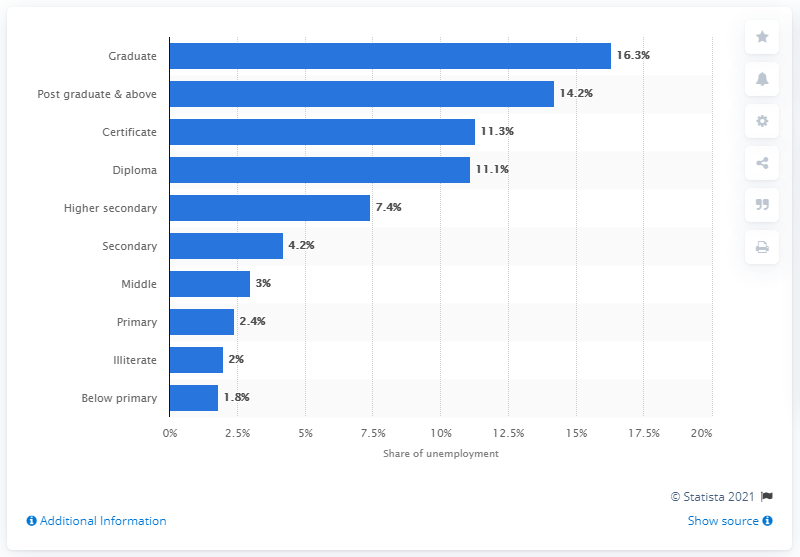Can you infer from the image which degree levels have almost the same rate of unemployment? Yes, according to the image, individuals with diploma and certificate qualifications have nearly identical unemployment rates, both at approximately 11.3%.  What does this similarity suggest about employment opportunities for those with diploma and certificate qualifications? This similarity implies that the employment opportunities for individuals with diploma and certificate qualifications may be comparable, suggesting that employers might value these two levels of education similarly when considering candidates for available positions. 